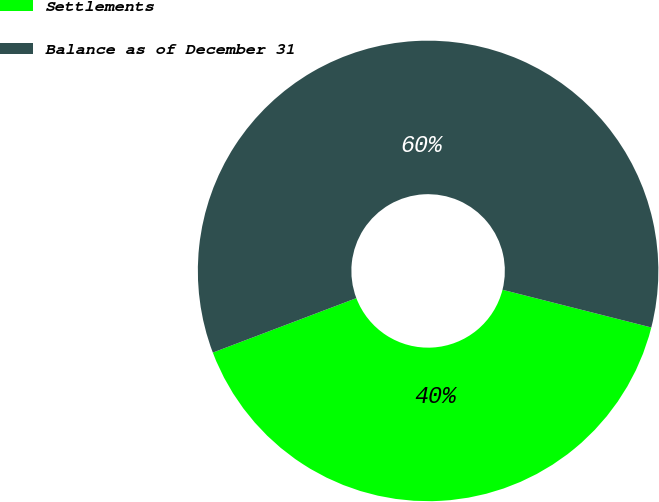Convert chart. <chart><loc_0><loc_0><loc_500><loc_500><pie_chart><fcel>Settlements<fcel>Balance as of December 31<nl><fcel>40.28%<fcel>59.72%<nl></chart> 